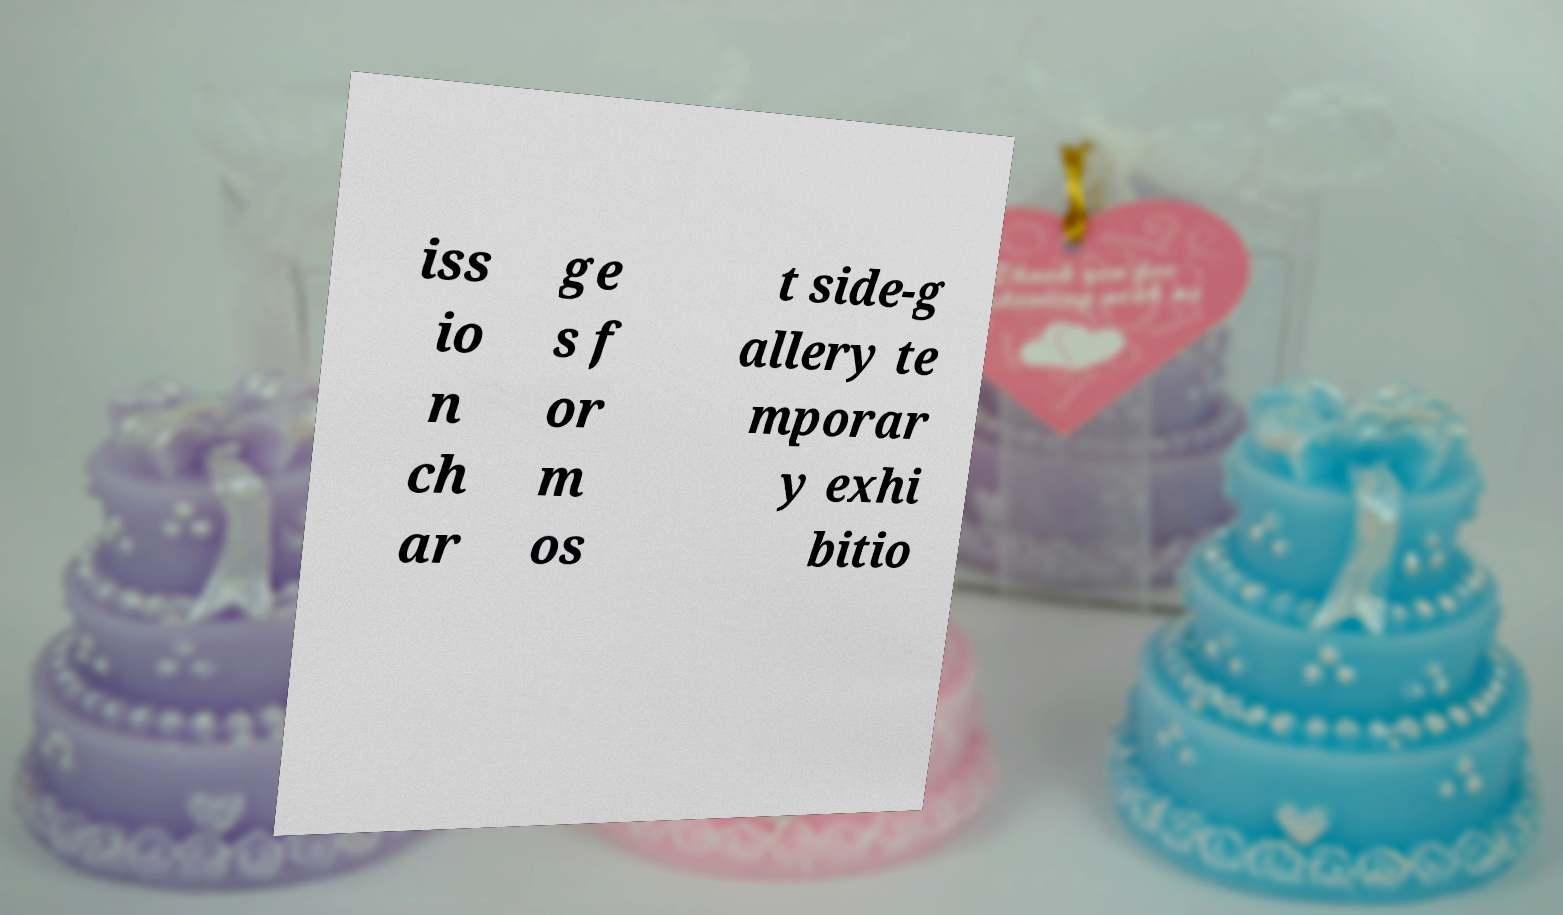I need the written content from this picture converted into text. Can you do that? iss io n ch ar ge s f or m os t side-g allery te mporar y exhi bitio 